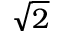Convert formula to latex. <formula><loc_0><loc_0><loc_500><loc_500>\sqrt { 2 }</formula> 